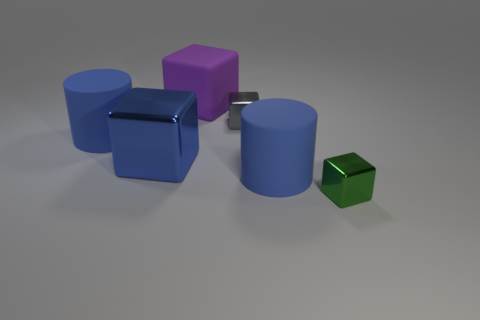Add 4 green cubes. How many objects exist? 10 Subtract all cubes. How many objects are left? 2 Add 5 large blue matte cylinders. How many large blue matte cylinders exist? 7 Subtract 0 gray spheres. How many objects are left? 6 Subtract all big rubber things. Subtract all large matte objects. How many objects are left? 0 Add 1 blue matte objects. How many blue matte objects are left? 3 